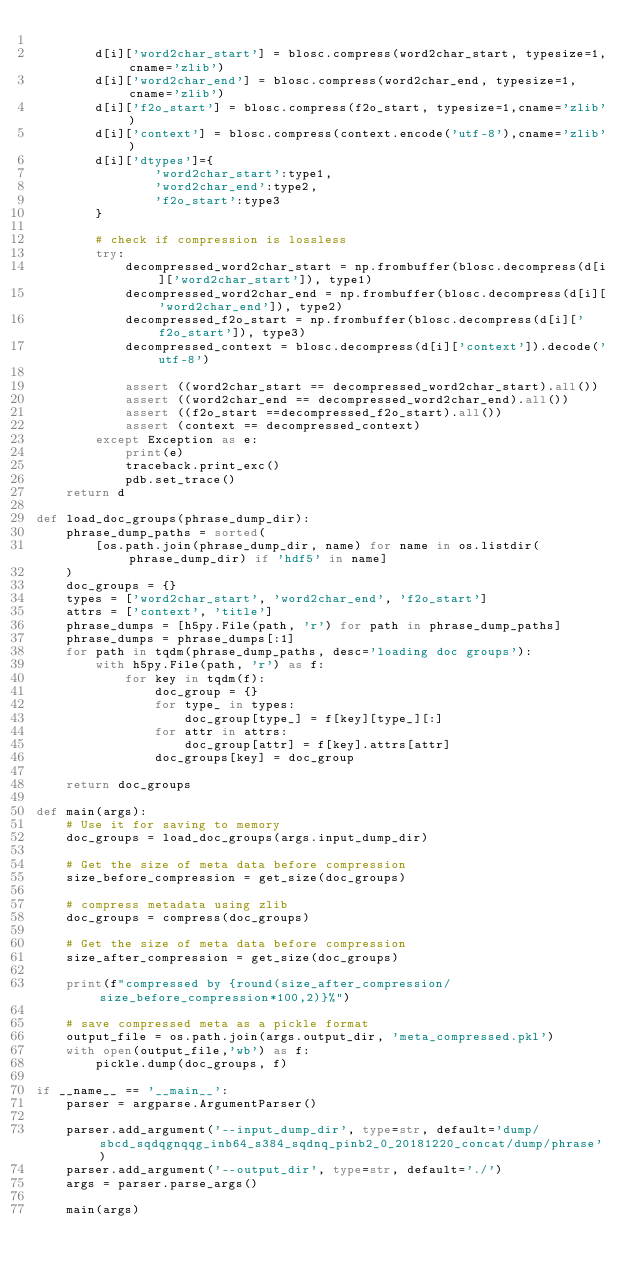<code> <loc_0><loc_0><loc_500><loc_500><_Python_>        
        d[i]['word2char_start'] = blosc.compress(word2char_start, typesize=1,cname='zlib')
        d[i]['word2char_end'] = blosc.compress(word2char_end, typesize=1,cname='zlib')
        d[i]['f2o_start'] = blosc.compress(f2o_start, typesize=1,cname='zlib')
        d[i]['context'] = blosc.compress(context.encode('utf-8'),cname='zlib')
        d[i]['dtypes']={
                'word2char_start':type1,
                'word2char_end':type2,
                'f2o_start':type3
        }

        # check if compression is lossless
        try:
            decompressed_word2char_start = np.frombuffer(blosc.decompress(d[i]['word2char_start']), type1)
            decompressed_word2char_end = np.frombuffer(blosc.decompress(d[i]['word2char_end']), type2)
            decompressed_f2o_start = np.frombuffer(blosc.decompress(d[i]['f2o_start']), type3)
            decompressed_context = blosc.decompress(d[i]['context']).decode('utf-8')

            assert ((word2char_start == decompressed_word2char_start).all())
            assert ((word2char_end == decompressed_word2char_end).all())
            assert ((f2o_start ==decompressed_f2o_start).all())
            assert (context == decompressed_context)
        except Exception as e:
            print(e)
            traceback.print_exc()
            pdb.set_trace()
    return d

def load_doc_groups(phrase_dump_dir):
    phrase_dump_paths = sorted(
        [os.path.join(phrase_dump_dir, name) for name in os.listdir(phrase_dump_dir) if 'hdf5' in name]
    )
    doc_groups = {}
    types = ['word2char_start', 'word2char_end', 'f2o_start']
    attrs = ['context', 'title']
    phrase_dumps = [h5py.File(path, 'r') for path in phrase_dump_paths]
    phrase_dumps = phrase_dumps[:1]
    for path in tqdm(phrase_dump_paths, desc='loading doc groups'):
        with h5py.File(path, 'r') as f:
            for key in tqdm(f):
                doc_group = {}
                for type_ in types:
                    doc_group[type_] = f[key][type_][:]
                for attr in attrs:
                    doc_group[attr] = f[key].attrs[attr]
                doc_groups[key] = doc_group

    return doc_groups

def main(args):
    # Use it for saving to memory
    doc_groups = load_doc_groups(args.input_dump_dir)

    # Get the size of meta data before compression
    size_before_compression = get_size(doc_groups)

    # compress metadata using zlib
    doc_groups = compress(doc_groups)

    # Get the size of meta data before compression
    size_after_compression = get_size(doc_groups)

    print(f"compressed by {round(size_after_compression/size_before_compression*100,2)}%")

    # save compressed meta as a pickle format
    output_file = os.path.join(args.output_dir, 'meta_compressed.pkl')
    with open(output_file,'wb') as f:
        pickle.dump(doc_groups, f)

if __name__ == '__main__':
    parser = argparse.ArgumentParser()

    parser.add_argument('--input_dump_dir', type=str, default='dump/sbcd_sqdqgnqqg_inb64_s384_sqdnq_pinb2_0_20181220_concat/dump/phrase')
    parser.add_argument('--output_dir', type=str, default='./')
    args = parser.parse_args()
    
    main(args)
</code> 